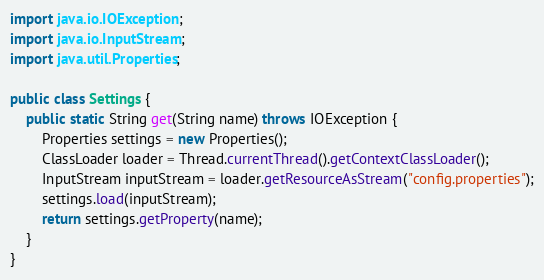<code> <loc_0><loc_0><loc_500><loc_500><_Java_>
import java.io.IOException;
import java.io.InputStream;
import java.util.Properties;

public class Settings {
    public static String get(String name) throws IOException {
        Properties settings = new Properties();
        ClassLoader loader = Thread.currentThread().getContextClassLoader();
        InputStream inputStream = loader.getResourceAsStream("config.properties");
        settings.load(inputStream);
        return settings.getProperty(name);
    }
}
</code> 